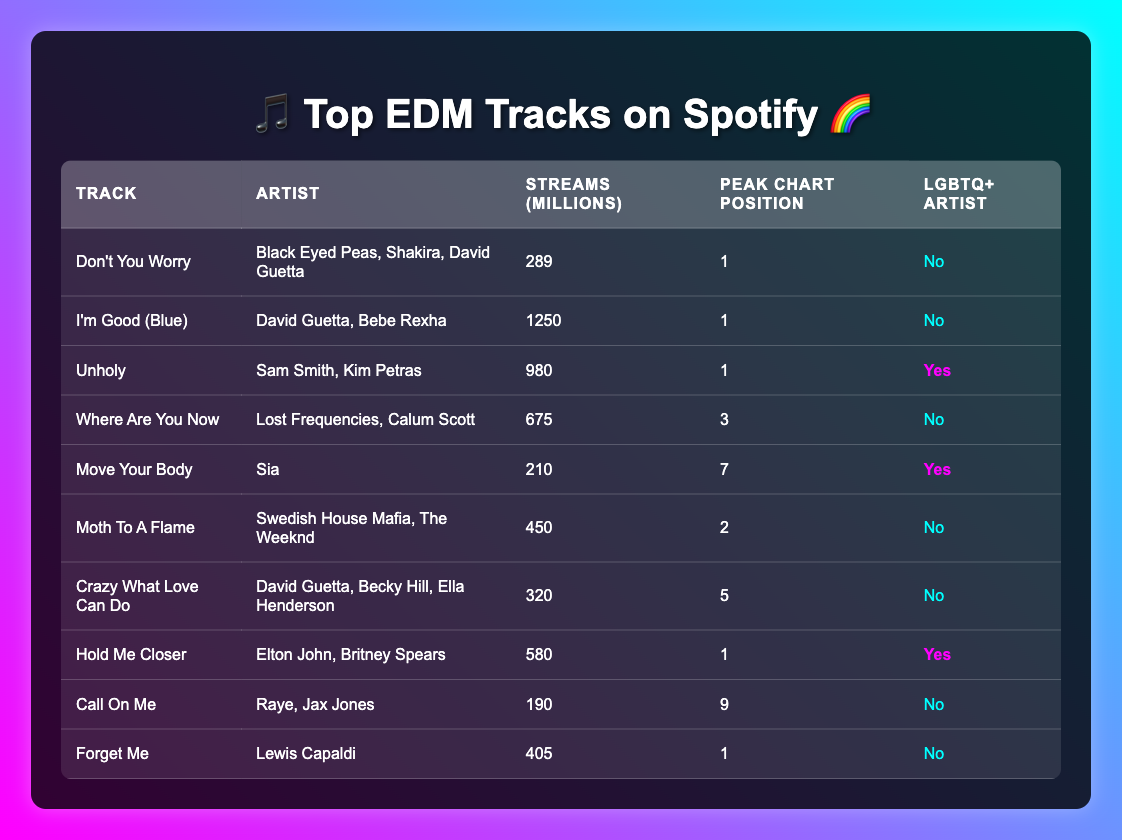What is the most streamed track in the table? The most streamed track is "I'm Good (Blue)" with 1250 million streams. I found this information by reading through the "Streams (millions)" column and identifying the highest value.
Answer: 1250 million How many LGBTQ+ artists are featured in the table? The table has three tracks by LGBTQ+ artists: "Unholy" by Sam Smith and Kim Petras, "Move Your Body" by Sia, and "Hold Me Closer" by Elton John and Britney Spears. This was determined by counting the entries marked "Yes" in the "LGBTQ+ Artist" column.
Answer: 3 What is the average number of streams for all the tracks listed? To find the average, I added all the stream counts: 289 + 1250 + 980 + 675 + 210 + 450 + 320 + 580 + 190 + 405 = 4,049 million. There are 10 tracks, so the average is 4,049 / 10 = 404.9 million streams.
Answer: 404.9 million Which track has the highest peak chart position and what is it? The highest peak chart position is 1, which is shared by the tracks "Don't You Worry," "I'm Good (Blue)," "Unholy," and "Hold Me Closer." I identified this by checking the "Peak Chart Position" column for the lowest number.
Answer: 1 Are there any tracks by LGBTQ+ artists that reached the peak chart position of 1? Yes, the tracks "Unholy" and "Hold Me Closer" have LGBTQ+ artists and they both peaked at position 1. I confirmed this by looking at the "LGBTQ+ Artist" column and checking the corresponding "Peak Chart Position" for those entries marked "Yes."
Answer: Yes 